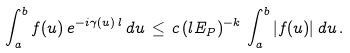Convert formula to latex. <formula><loc_0><loc_0><loc_500><loc_500>\int _ { a } ^ { b } f ( u ) \, e ^ { - i \gamma ( u ) \, l } \, d u \, \leq \, c \, ( l E _ { P } ) ^ { - k } \, \int _ { a } ^ { b } | f ( u ) | \, d u \, .</formula> 